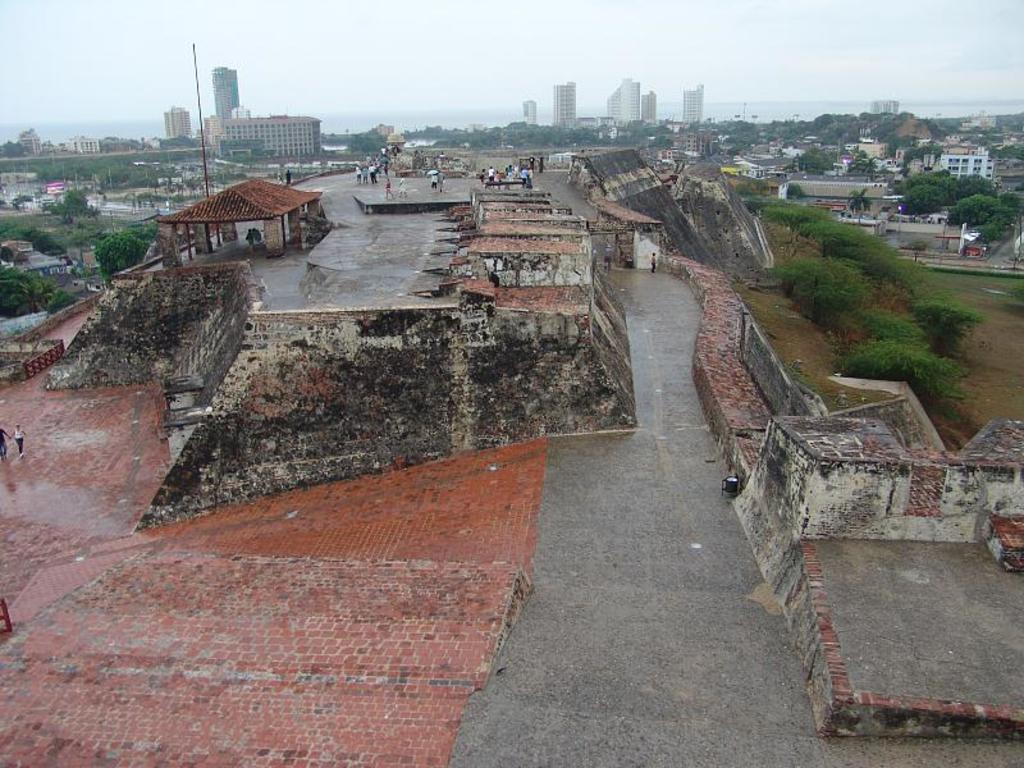Please provide a concise description of this image. In the picture we can see some houses on the hill path and near it, we can see some people and in the background, we can see houses, buildings, tower buildings and sky. 